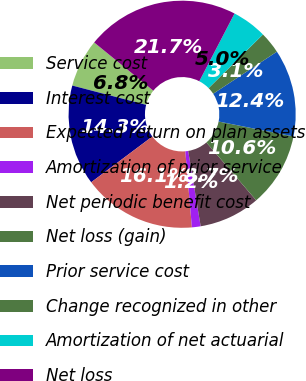Convert chart. <chart><loc_0><loc_0><loc_500><loc_500><pie_chart><fcel>Service cost<fcel>Interest cost<fcel>Expected return on plan assets<fcel>Amortization of prior service<fcel>Net periodic benefit cost<fcel>Net loss (gain)<fcel>Prior service cost<fcel>Change recognized in other<fcel>Amortization of net actuarial<fcel>Net loss<nl><fcel>6.83%<fcel>14.29%<fcel>16.15%<fcel>1.24%<fcel>8.7%<fcel>10.56%<fcel>12.42%<fcel>3.11%<fcel>4.97%<fcel>21.74%<nl></chart> 